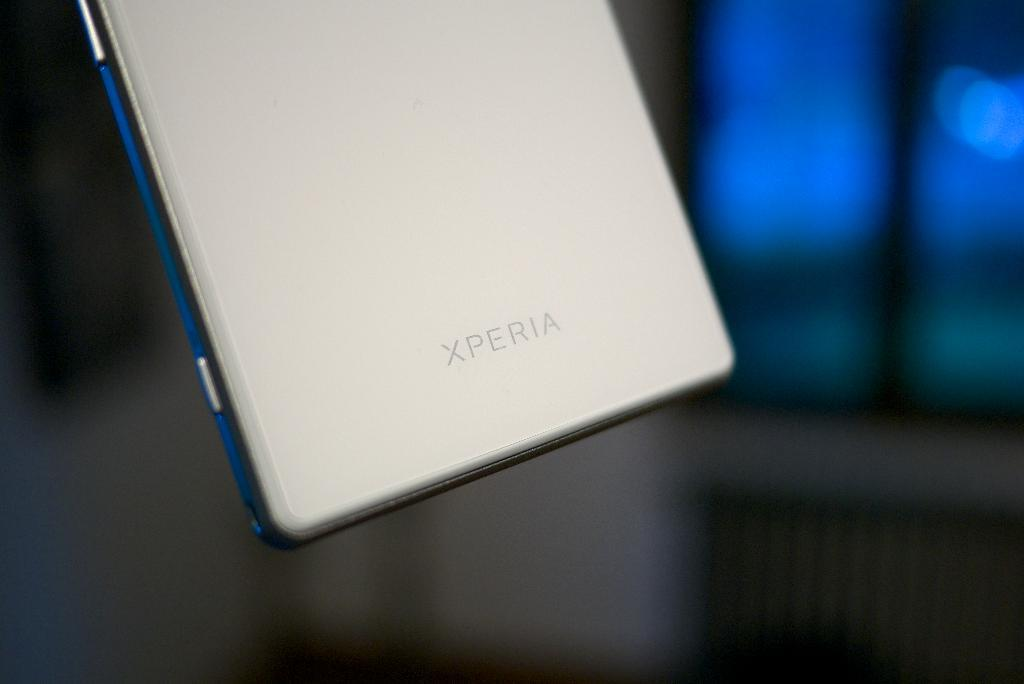<image>
Share a concise interpretation of the image provided. the back of a white phone that is labeled as 'xperia' brand 